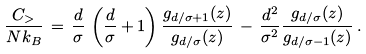<formula> <loc_0><loc_0><loc_500><loc_500>\frac { C _ { > } } { N k _ { B } } \, = \, \frac { d } { \sigma } \, \left ( \frac { d } { \sigma } + 1 \right ) \frac { g _ { d / \sigma + 1 } ( z ) } { g _ { d / \sigma } ( z ) } \, - \, \frac { d ^ { 2 } } { \sigma ^ { 2 } } \frac { g _ { d / \sigma } ( z ) } { g _ { d / \sigma - 1 } ( z ) } \, .</formula> 